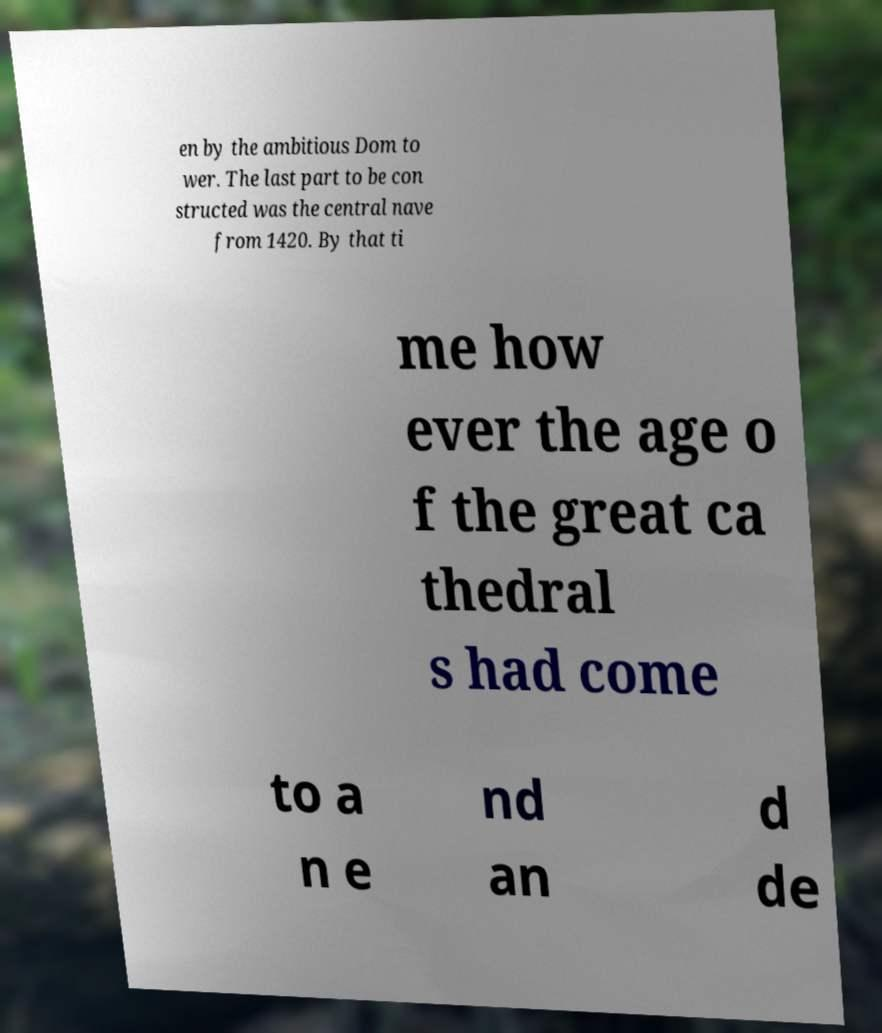Can you read and provide the text displayed in the image?This photo seems to have some interesting text. Can you extract and type it out for me? en by the ambitious Dom to wer. The last part to be con structed was the central nave from 1420. By that ti me how ever the age o f the great ca thedral s had come to a n e nd an d de 